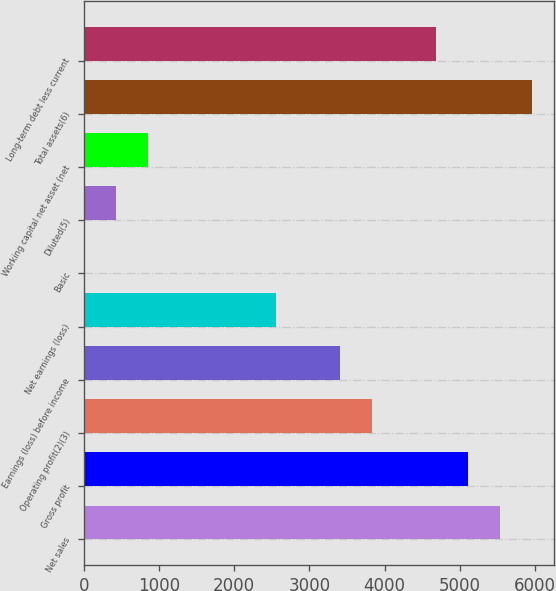Convert chart to OTSL. <chart><loc_0><loc_0><loc_500><loc_500><bar_chart><fcel>Net sales<fcel>Gross profit<fcel>Operating profit(2)(3)<fcel>Earnings (loss) before income<fcel>Net earnings (loss)<fcel>Basic<fcel>Diluted(5)<fcel>Working capital net asset (net<fcel>Total assets(6)<fcel>Long-term debt less current<nl><fcel>5537.78<fcel>5112.12<fcel>3835.14<fcel>3409.48<fcel>2558.16<fcel>4.2<fcel>429.86<fcel>855.52<fcel>5963.44<fcel>4686.46<nl></chart> 